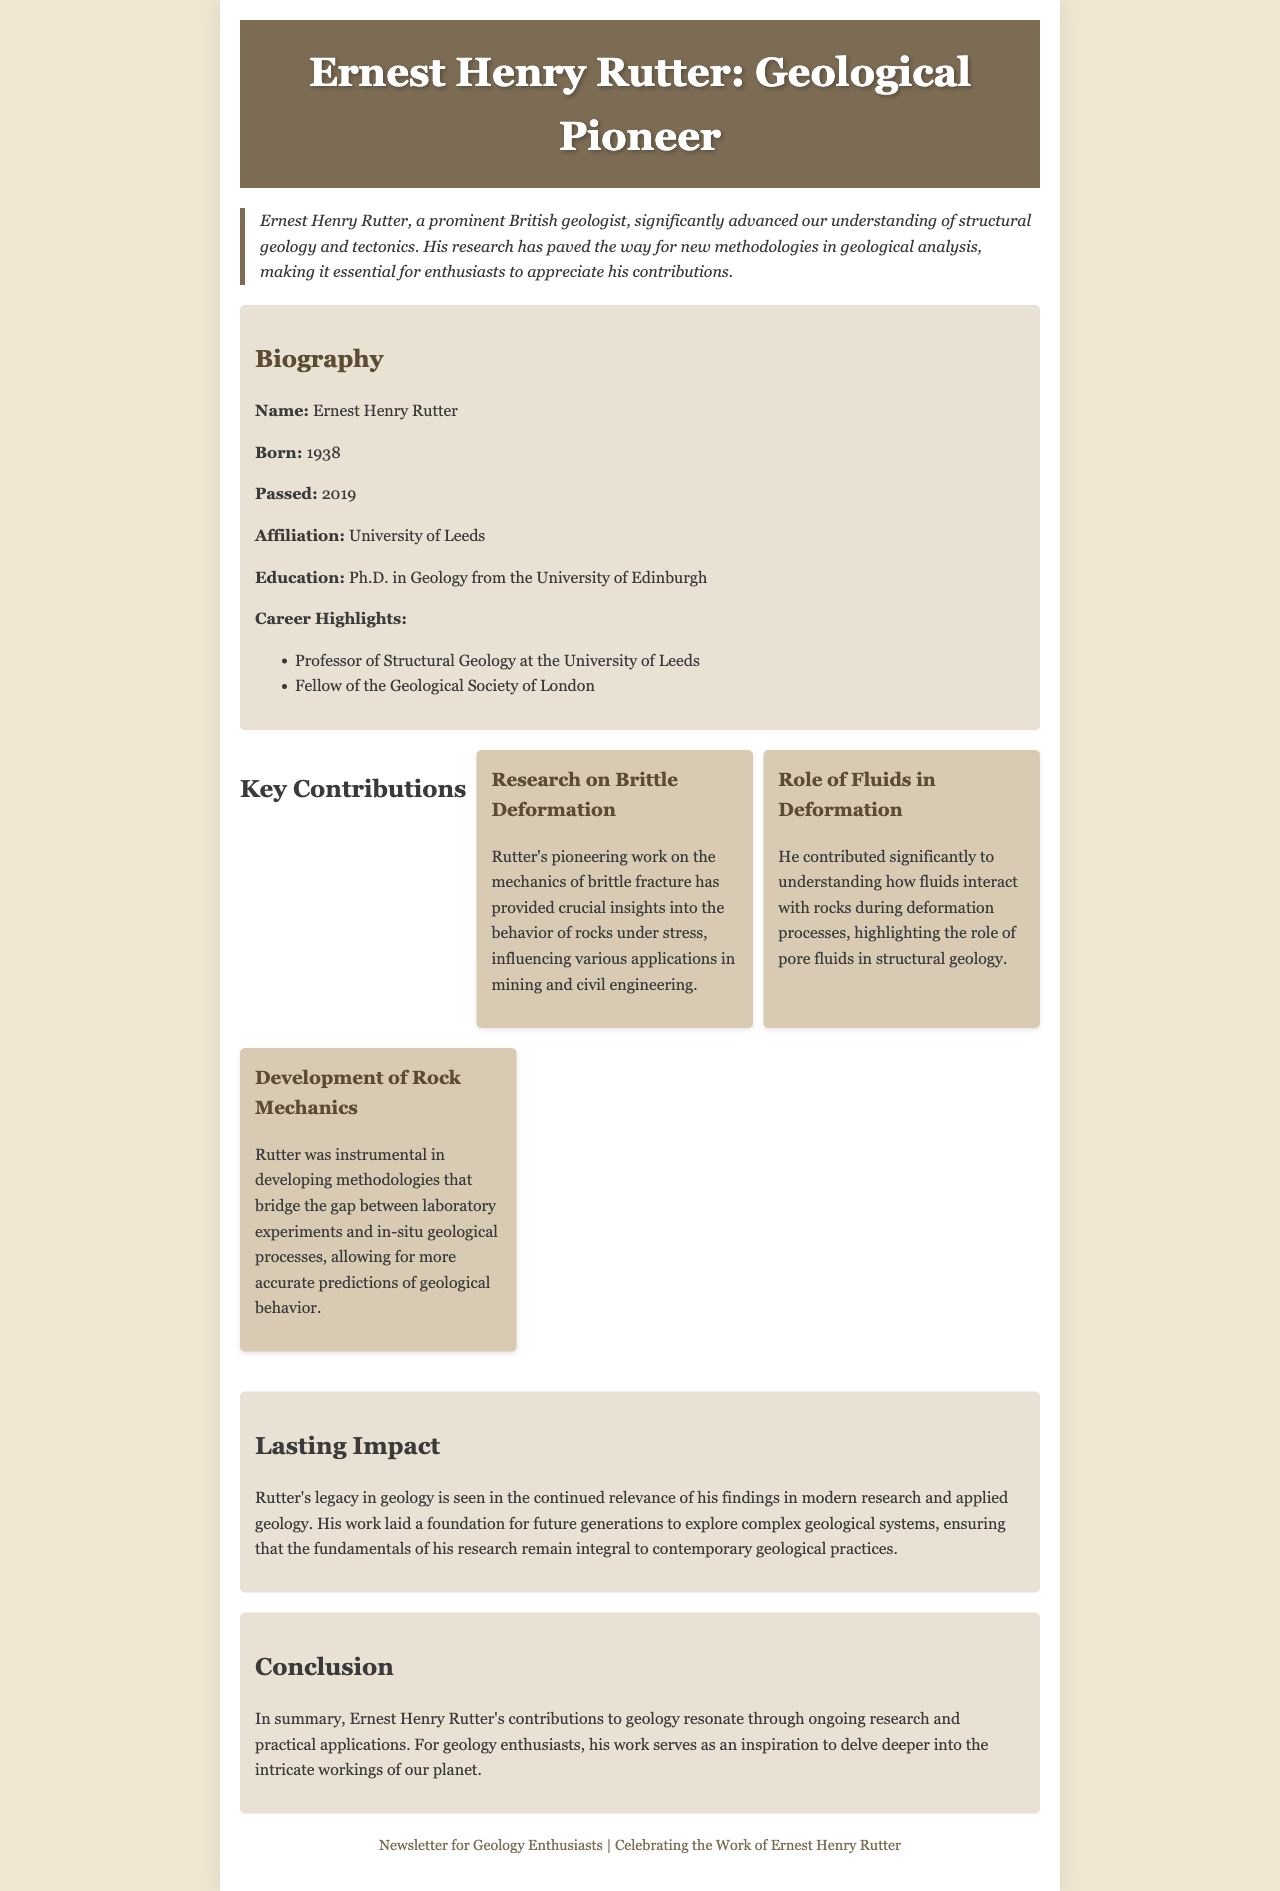What year was Ernest Henry Rutter born? The document states that Ernest Henry Rutter was born in 1938.
Answer: 1938 What was Rutter's affiliation at the time of his career? The document indicates that Rutter's affiliation was with the University of Leeds.
Answer: University of Leeds What is one of Rutter's key contributions to geology? The document lists several contributions, one being his research on brittle deformation.
Answer: Research on brittle deformation In which year did Ernest Henry Rutter pass away? According to the document, Rutter passed away in 2019.
Answer: 2019 What role did fluids play according to Rutter's research? The document mentions that Rutter highlighted the role of pore fluids in structural geology.
Answer: Role of pore fluids What educational degree did Rutter obtain? The document states that Rutter earned a Ph.D. in Geology.
Answer: Ph.D. in Geology What is one impact of Rutter's research? The document notes that Rutter's findings remain relevant in modern research and applied geology.
Answer: Continued relevance How is Rutter's work summarized in the conclusion? The document concludes by stating that Rutter's contributions resonate through ongoing research and practical applications.
Answer: Resonates through ongoing research What is the main topic of this newsletter? The document's title indicates that the main topic is a profile on Ernest Henry Rutter and his contributions to geology.
Answer: Profile on Ernest Henry Rutter 